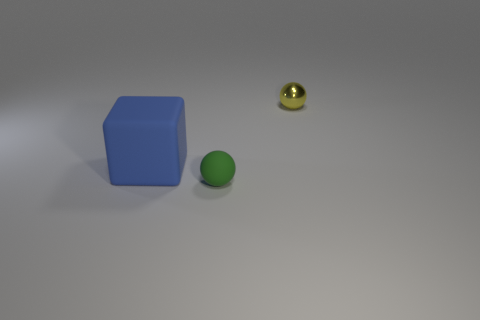Add 3 brown metal cubes. How many objects exist? 6 Subtract all balls. How many objects are left? 1 Subtract all big blue rubber objects. Subtract all tiny rubber balls. How many objects are left? 1 Add 3 large blue objects. How many large blue objects are left? 4 Add 1 large brown cylinders. How many large brown cylinders exist? 1 Subtract 0 red spheres. How many objects are left? 3 